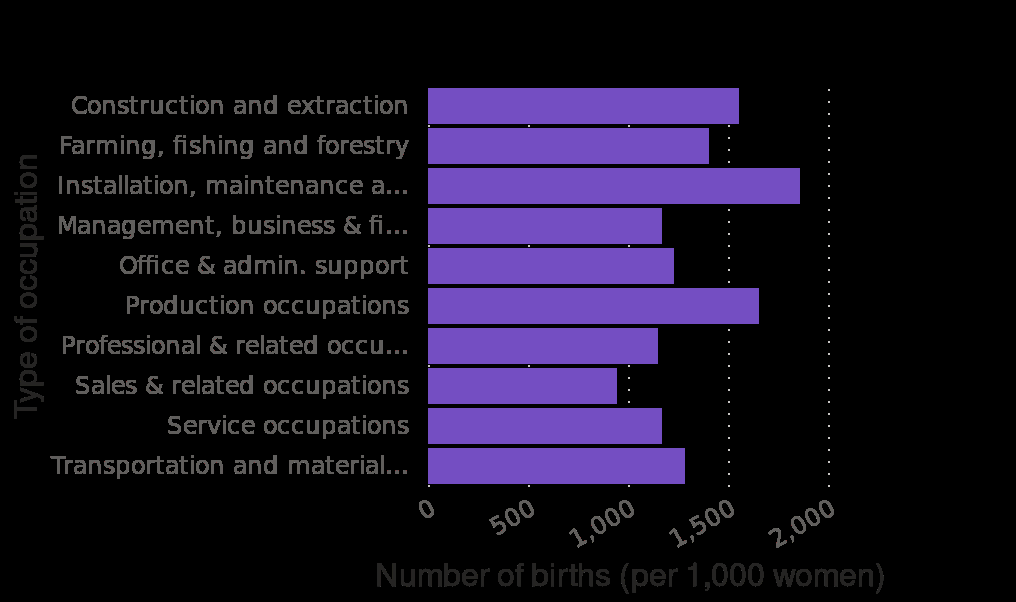<image>
What does the data suggest about the relationship between births and the number of women in most areas? The data suggests that in most areas, the number of births per 1000 women is equal to or greater than the number of women. please describe the details of the chart Number of births (per 1,000 women) by occupation of mother in the United States in 2012 is a bar chart. A categorical scale with Construction and extraction on one end and  at the other can be found along the y-axis, marked Type of occupation. A linear scale with a minimum of 0 and a maximum of 2,000 can be found along the x-axis, marked Number of births (per 1,000 women). 